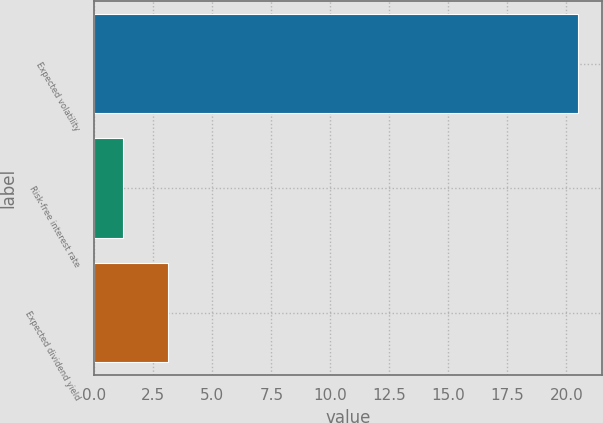Convert chart to OTSL. <chart><loc_0><loc_0><loc_500><loc_500><bar_chart><fcel>Expected volatility<fcel>Risk-free interest rate<fcel>Expected dividend yield<nl><fcel>20.5<fcel>1.2<fcel>3.13<nl></chart> 